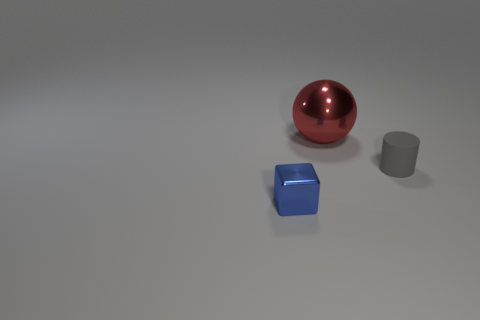Add 3 small green rubber balls. How many objects exist? 6 Subtract all spheres. How many objects are left? 2 Add 1 tiny brown spheres. How many tiny brown spheres exist? 1 Subtract 0 yellow cubes. How many objects are left? 3 Subtract all big cyan metallic cylinders. Subtract all large red shiny objects. How many objects are left? 2 Add 2 tiny blue blocks. How many tiny blue blocks are left? 3 